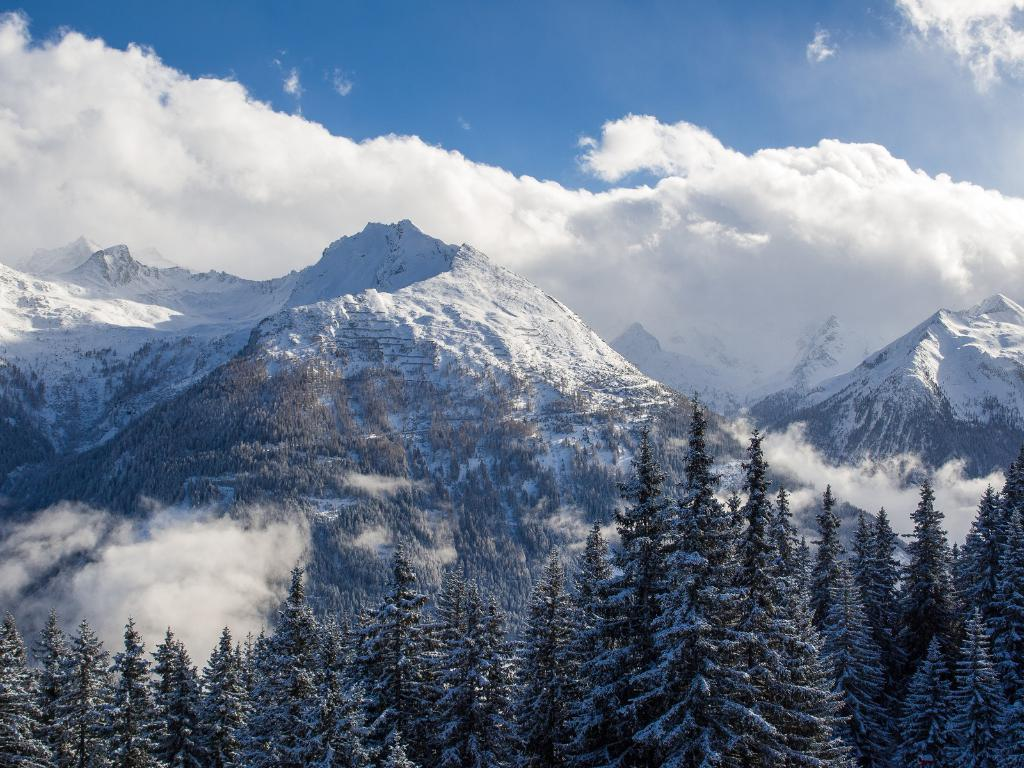What type of natural environment is depicted in the image? The image shows trees covered with snow, indicating a winter landscape. What atmospheric condition can be observed in the image? There is fog visible in the image. What geographical features are present in the image? There are mountains in the image. What is the color of the sky in the background? The sky is blue in the background. What else can be seen in the sky besides the blue color? Clouds are present in the sky. What type of joke is being told by the hook in the image? There is no hook present in the image, and therefore no joke can be associated with it. 